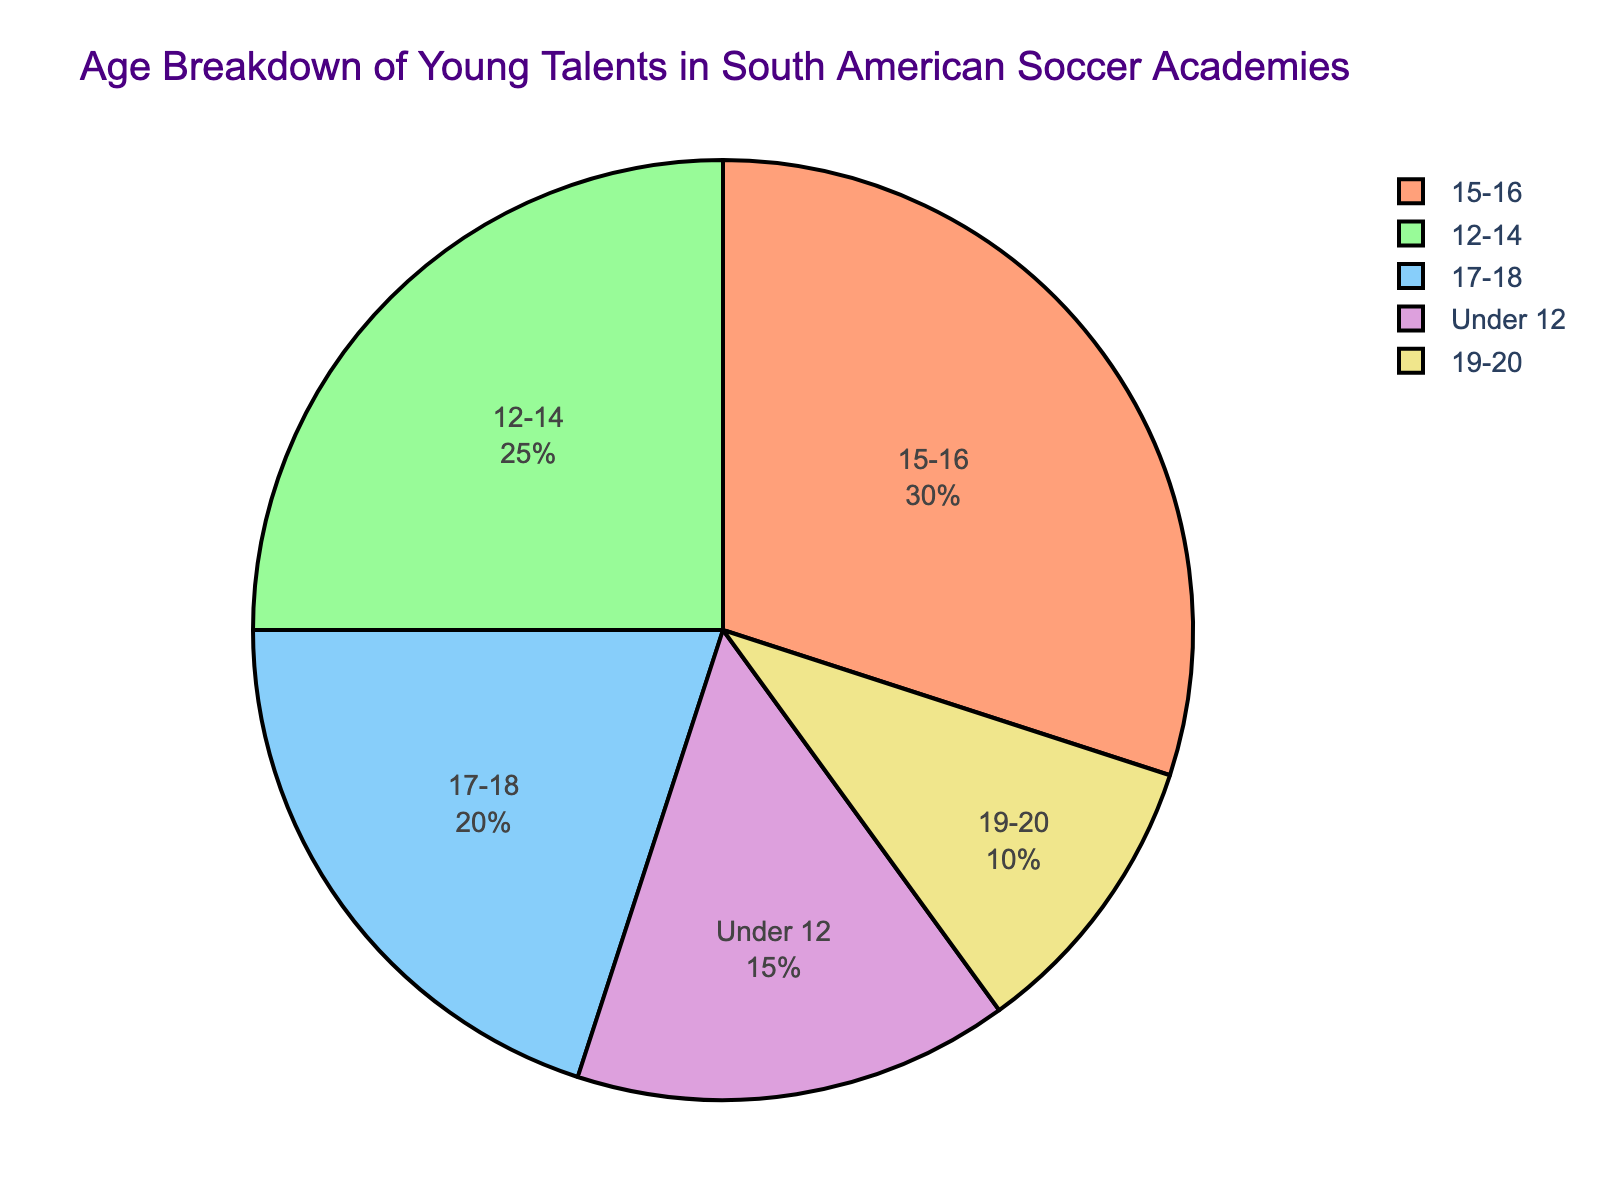Which age group has the most substantial percentage of young talents in South American soccer academies? By examining the figure, notice the relative sizes of the pie slices. The 15-16 age group has the largest slice.
Answer: 15-16 Which age groups combined constitute over half of the young talents in South American soccer academies? By adding the percentages from the chart, 15-16 (30%) and 12-14 (25%) together make 55%.
Answer: 15-16 and 12-14 How much more percentage do players aged 15-16 represent compared to players aged 19-20? Subtracting the percentage of the 19-20 age group (10%) from the 15-16 age group (30%), we get 20%.
Answer: 20% How does the percentage of players in the 17-18 age group compare to the percentage of players in the 12-14 age group? The 17-18 age group is represented by 20%, while the 12-14 age group is represented by 25%, hence the 12-14 group is larger.
Answer: 12-14 group is larger Which two age groups have almost similar proportions of talents, and how much do they differ? The 17-18 age group (20%) and Under 12 age group (15%) are close in size. The difference is 5%.
Answer: 17-18 and Under 12; 5% If we were to combine the percentage of the youngest and oldest groups, what would be their combined proportion? Adding the percentages of Under 12 (15%) and 19-20 (10%) results in 25%.
Answer: 25% What color represents the 12-14 age group in the pie chart? Looking at the pie chart, the 12-14 age group is represented in green.
Answer: green What is the difference between the combined percentage of the 15-16 and 17-18 age groups and the percentage of the Under 12 group? Adding 15-16 (30%) and 17-18 (20%) gives 50%. Subtracting Under 12 (15%), we get 35%.
Answer: 35% Which age group is represented by the smallest proportion of young soccer talents? The smallest slice on the pie chart is the 19-20 age group, which constitutes 10%.
Answer: 19-20 Are the players aged 17-18 more or less than the combined total of Under 12 and 19-20 groups? The Under 12 group has 15%, and the 19-20 group has 10%. Combined, they are 25%. The 17-18 group has 20%, which is less.
Answer: less 